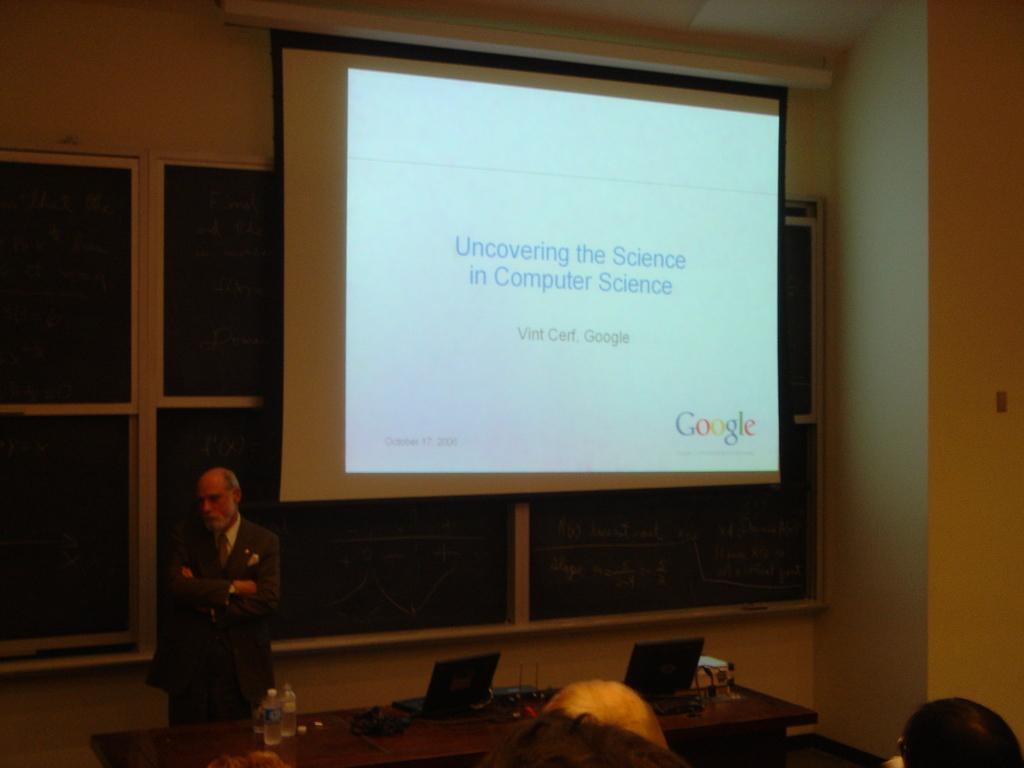Describe this image in one or two sentences. This is the picture of a room. In this image there is a person standing behind the table. There are laptops, bottles and devices on the table. At the back there is a screen and there is a text on the screen. In the foreground there are group of people. 